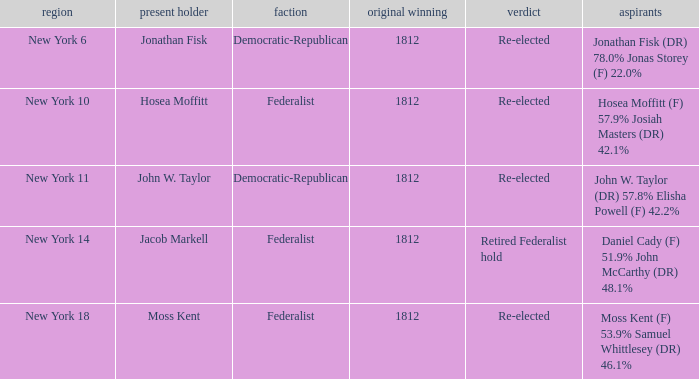Name the incumbent for new york 10 Hosea Moffitt. 